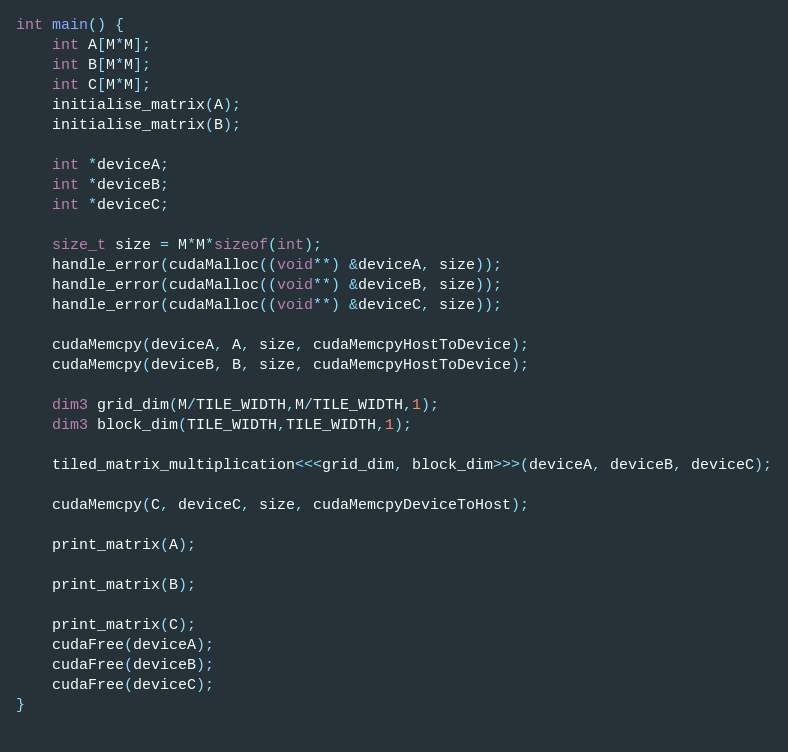Convert code to text. <code><loc_0><loc_0><loc_500><loc_500><_Cuda_>int main() {
	int A[M*M];
	int B[M*M];
	int C[M*M];
	initialise_matrix(A);
	initialise_matrix(B);
	
	int *deviceA;
	int *deviceB;
	int *deviceC;
	
	size_t size = M*M*sizeof(int);
	handle_error(cudaMalloc((void**) &deviceA, size));
	handle_error(cudaMalloc((void**) &deviceB, size));
	handle_error(cudaMalloc((void**) &deviceC, size));
	
	cudaMemcpy(deviceA, A, size, cudaMemcpyHostToDevice);
	cudaMemcpy(deviceB, B, size, cudaMemcpyHostToDevice);
	
	dim3 grid_dim(M/TILE_WIDTH,M/TILE_WIDTH,1);
	dim3 block_dim(TILE_WIDTH,TILE_WIDTH,1);
	
	tiled_matrix_multiplication<<<grid_dim, block_dim>>>(deviceA, deviceB, deviceC);
	
	cudaMemcpy(C, deviceC, size, cudaMemcpyDeviceToHost);

	print_matrix(A);
	
	print_matrix(B);
	
	print_matrix(C);	
	cudaFree(deviceA);
	cudaFree(deviceB);
	cudaFree(deviceC);
}
	

</code> 